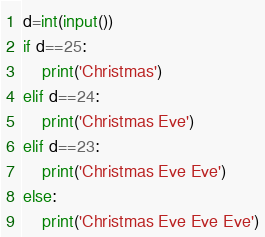<code> <loc_0><loc_0><loc_500><loc_500><_Python_>d=int(input())
if d==25:
    print('Christmas')
elif d==24:
    print('Christmas Eve')
elif d==23:
    print('Christmas Eve Eve')
else:
    print('Christmas Eve Eve Eve')</code> 